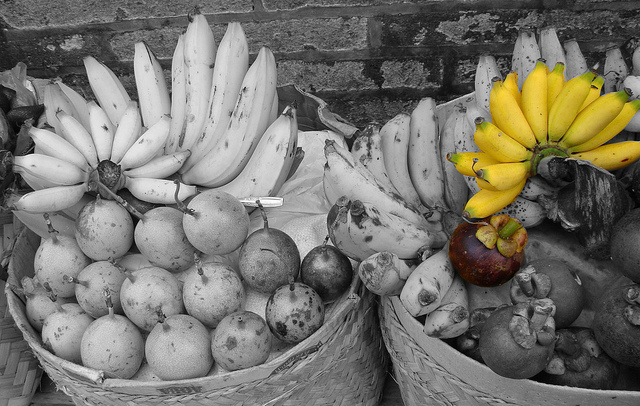Please provide the bounding box coordinate of the region this sentence describes: white banana beside yellow. The region corresponding to 'white banana beside yellow' is located at coordinates [0.49, 0.34, 0.74, 0.59]. 